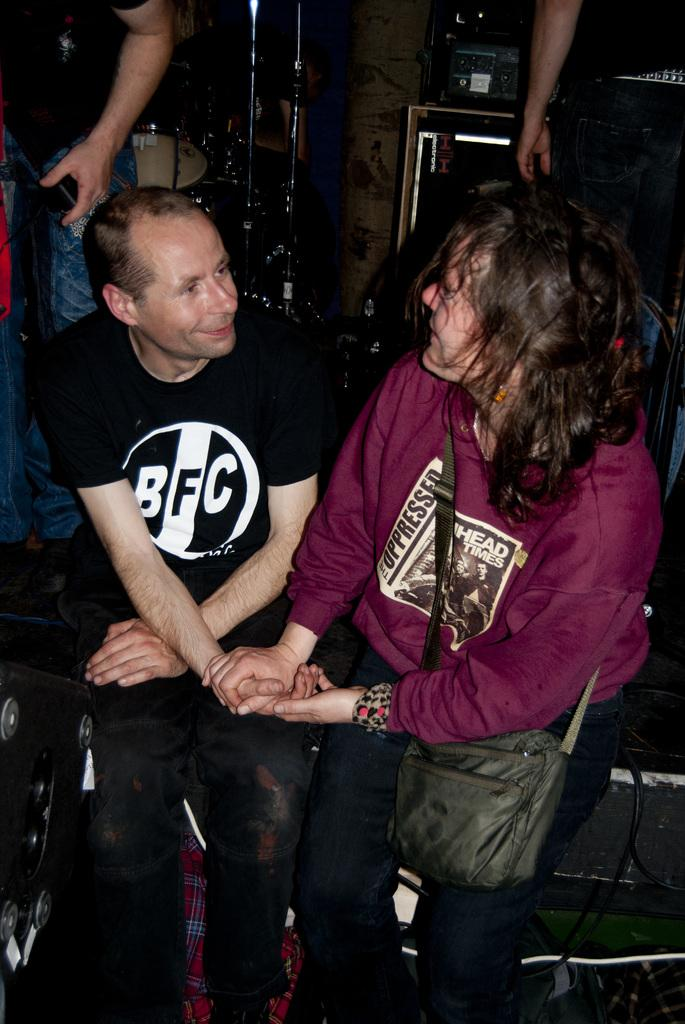Provide a one-sentence caption for the provided image. A young woman holds hands with a man in a black BFC t-shirt. 